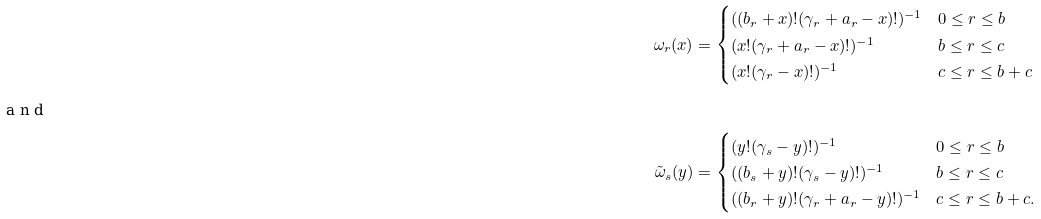<formula> <loc_0><loc_0><loc_500><loc_500>\omega _ { r } ( x ) & = \begin{cases} ( ( b _ { r } + x ) ! ( \gamma _ { r } + a _ { r } - x ) ! ) ^ { - 1 } & 0 \leq r \leq b \\ ( x ! ( \gamma _ { r } + a _ { r } - x ) ! ) ^ { - 1 } & b \leq r \leq c \\ ( x ! ( \gamma _ { r } - x ) ! ) ^ { - 1 } & c \leq r \leq b + c \end{cases} \\ \intertext { a n d } \tilde { \omega } _ { s } ( y ) & = \begin{cases} ( y ! ( \gamma _ { s } - y ) ! ) ^ { - 1 } & 0 \leq r \leq b \\ ( ( b _ { s } + y ) ! ( \gamma _ { s } - y ) ! ) ^ { - 1 } & b \leq r \leq c \\ ( ( b _ { r } + y ) ! ( \gamma _ { r } + a _ { r } - y ) ! ) ^ { - 1 } & c \leq r \leq b + c . \end{cases}</formula> 